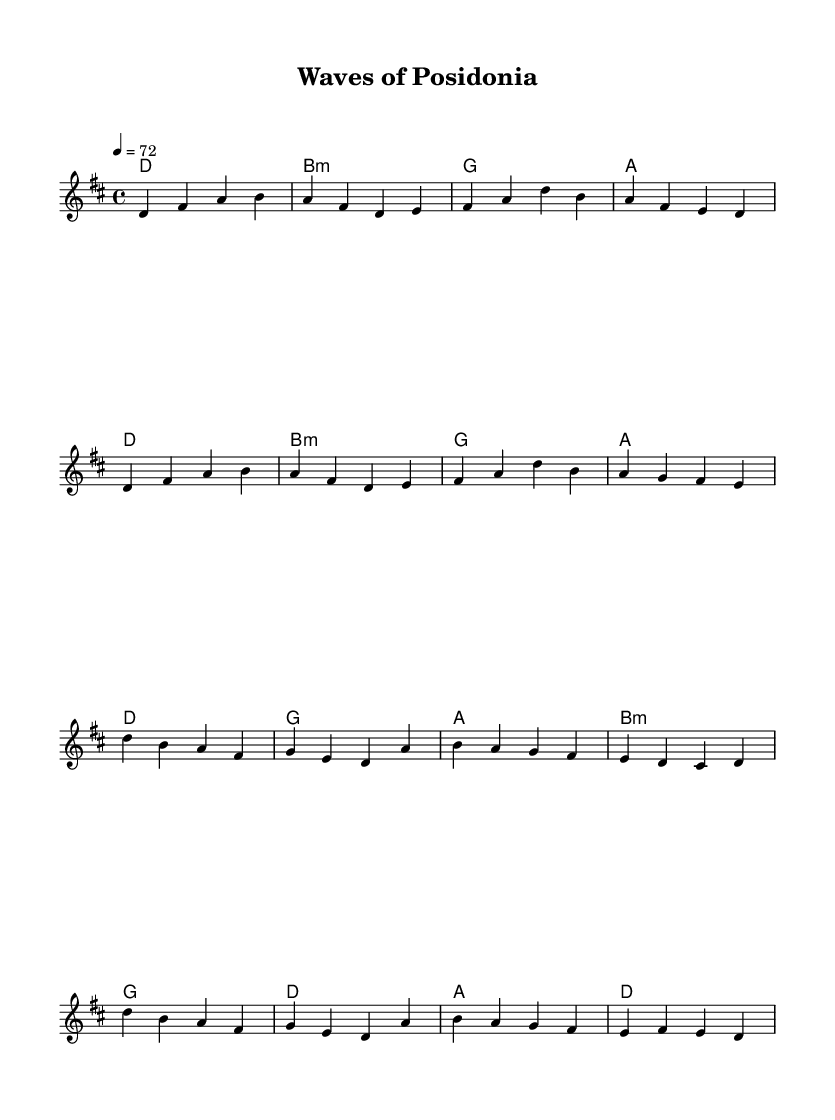What is the key signature of this music? The key signature is D major, which has two sharps (F# and C#). This can be identified in the sheet music where there are two sharp symbols placed at the beginning of the staff.
Answer: D major What is the time signature of this music? The time signature is 4/4, indicated at the beginning of the staff. This means there are four beats in a measure and the quarter note gets one beat.
Answer: 4/4 What is the tempo marking of this music? The tempo marking is 72 beats per minute, indicated as "4 = 72" at the beginning of the score. This marking defines how fast the piece should be played.
Answer: 72 How many measures are in the verse section? The verse section consists of 8 measures. This can be counted by looking at the music from the start of the verse to the end, indicated by the musical phrases.
Answer: 8 Which chord follows the first measure of the chorus? The chord following the first measure of the chorus is G major. This can be deduced by observing the chord changes beneath the melody, where the first chord in the chorus is G after the measure of D major.
Answer: G What is the last chord of the piece? The last chord of the piece is D major, as seen in the final measure of the score where the last chord is labeled clearly beneath the melody line.
Answer: D How does the melody of the chorus start? The melody of the chorus starts with the note D, as the first note in the chorus line is a D in the specified octave. This is visually confirmed on the staff.
Answer: D 